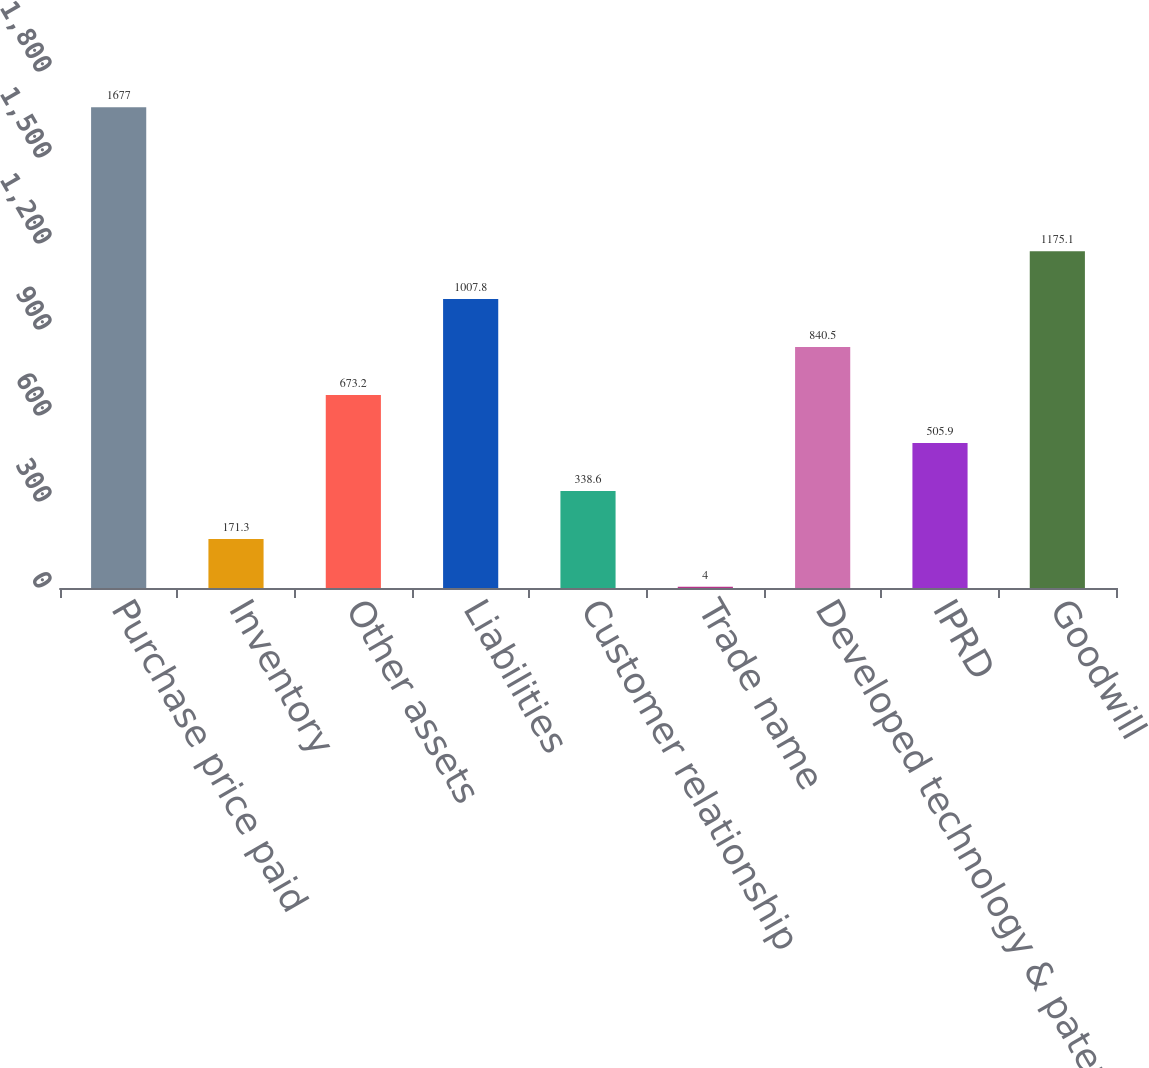<chart> <loc_0><loc_0><loc_500><loc_500><bar_chart><fcel>Purchase price paid<fcel>Inventory<fcel>Other assets<fcel>Liabilities<fcel>Customer relationship<fcel>Trade name<fcel>Developed technology & patents<fcel>IPRD<fcel>Goodwill<nl><fcel>1677<fcel>171.3<fcel>673.2<fcel>1007.8<fcel>338.6<fcel>4<fcel>840.5<fcel>505.9<fcel>1175.1<nl></chart> 